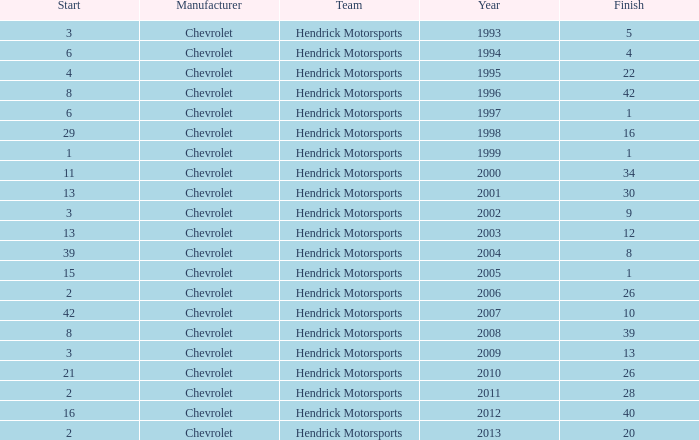What is the number of finishes having a start of 15? 1.0. 